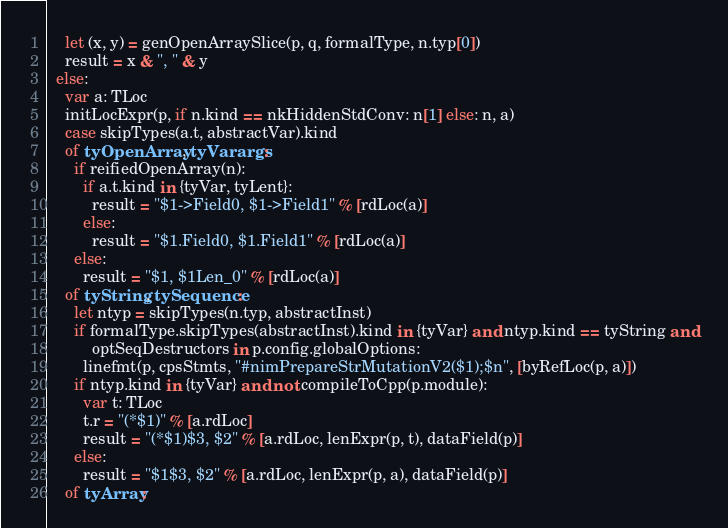Convert code to text. <code><loc_0><loc_0><loc_500><loc_500><_Nim_>    let (x, y) = genOpenArraySlice(p, q, formalType, n.typ[0])
    result = x & ", " & y
  else:
    var a: TLoc
    initLocExpr(p, if n.kind == nkHiddenStdConv: n[1] else: n, a)
    case skipTypes(a.t, abstractVar).kind
    of tyOpenArray, tyVarargs:
      if reifiedOpenArray(n):
        if a.t.kind in {tyVar, tyLent}:
          result = "$1->Field0, $1->Field1" % [rdLoc(a)]
        else:
          result = "$1.Field0, $1.Field1" % [rdLoc(a)]
      else:
        result = "$1, $1Len_0" % [rdLoc(a)]
    of tyString, tySequence:
      let ntyp = skipTypes(n.typ, abstractInst)
      if formalType.skipTypes(abstractInst).kind in {tyVar} and ntyp.kind == tyString and
          optSeqDestructors in p.config.globalOptions:
        linefmt(p, cpsStmts, "#nimPrepareStrMutationV2($1);$n", [byRefLoc(p, a)])
      if ntyp.kind in {tyVar} and not compileToCpp(p.module):
        var t: TLoc
        t.r = "(*$1)" % [a.rdLoc]
        result = "(*$1)$3, $2" % [a.rdLoc, lenExpr(p, t), dataField(p)]
      else:
        result = "$1$3, $2" % [a.rdLoc, lenExpr(p, a), dataField(p)]
    of tyArray:</code> 